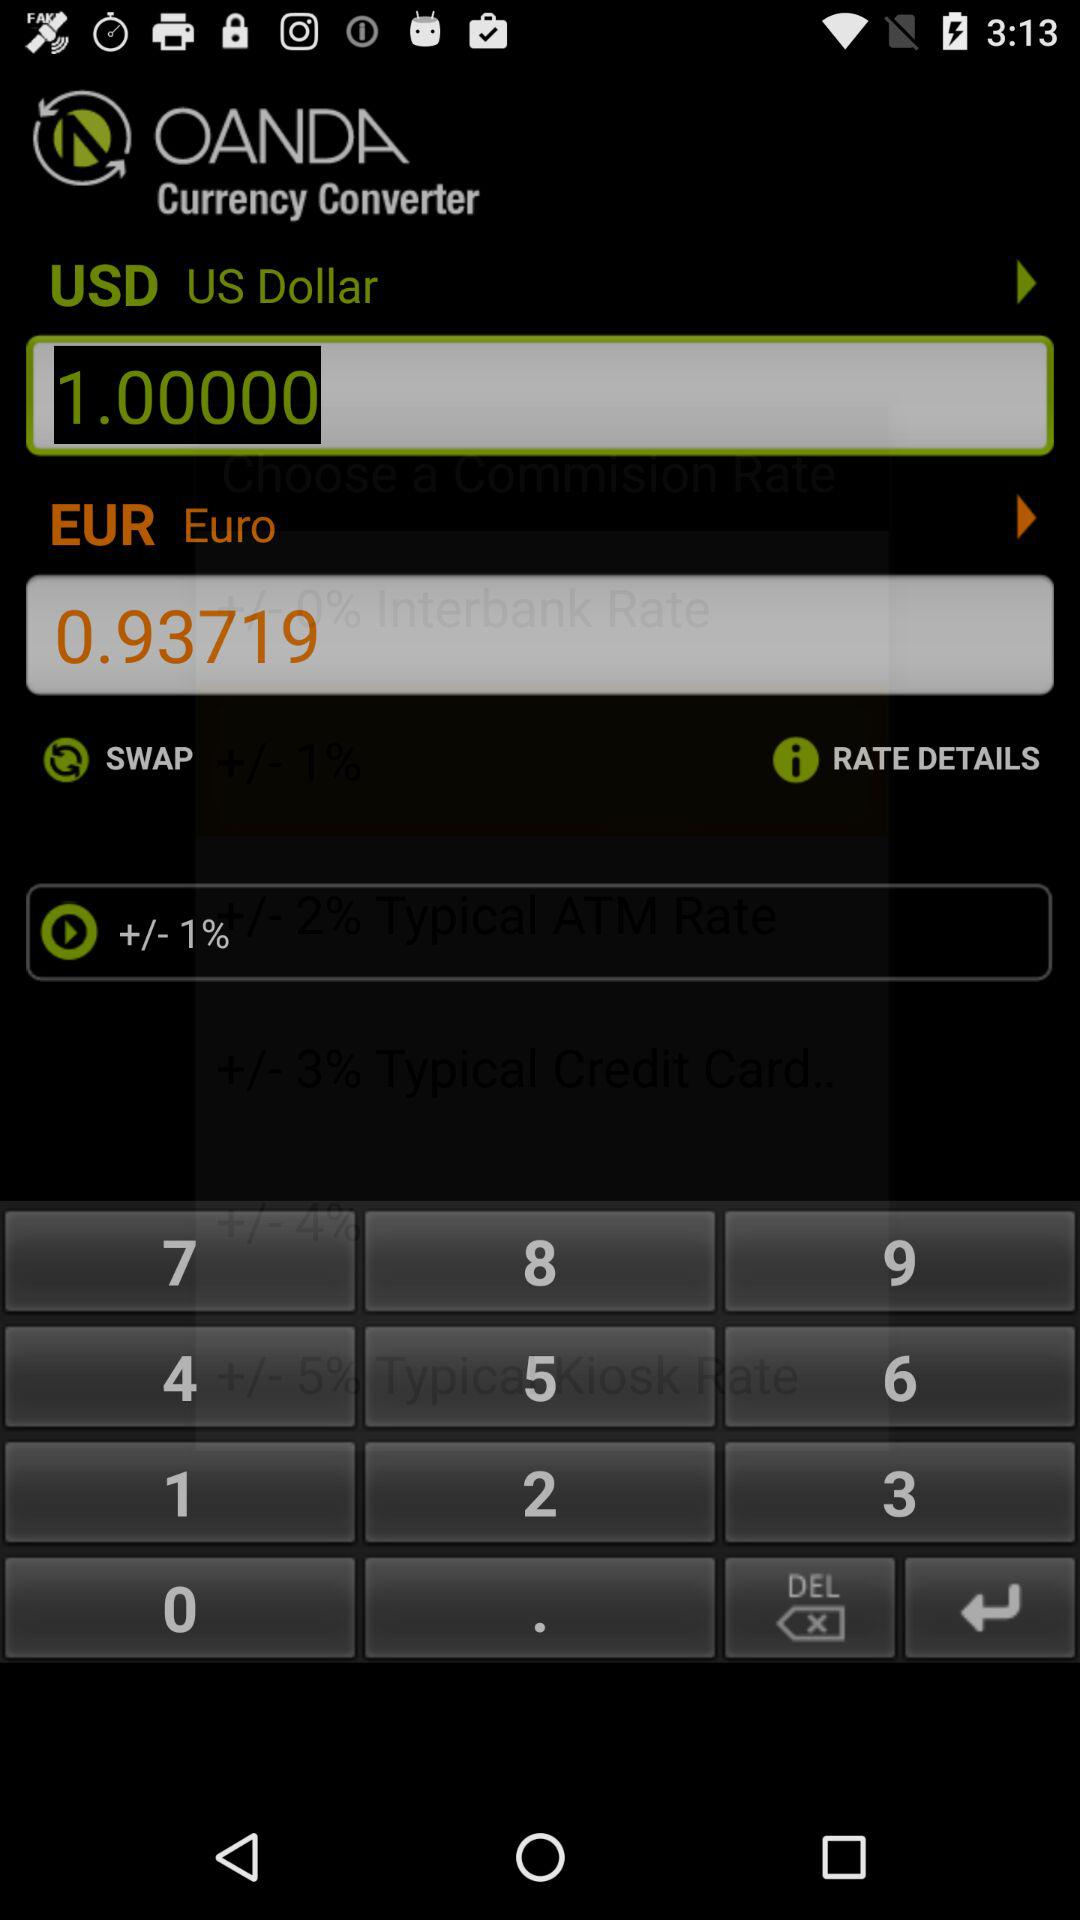What is the euro exchange rate for a dollar? The rate is 0.93719 euros per dollar. 